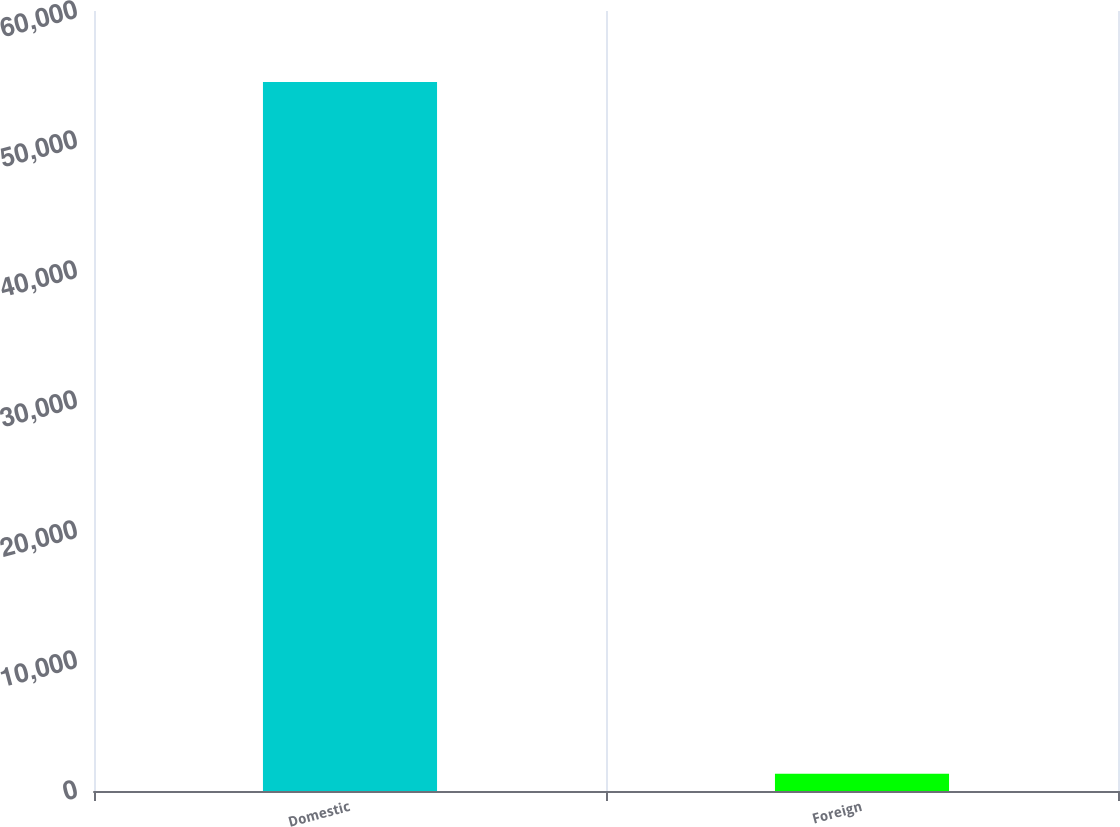Convert chart. <chart><loc_0><loc_0><loc_500><loc_500><bar_chart><fcel>Domestic<fcel>Foreign<nl><fcel>54542<fcel>1319<nl></chart> 